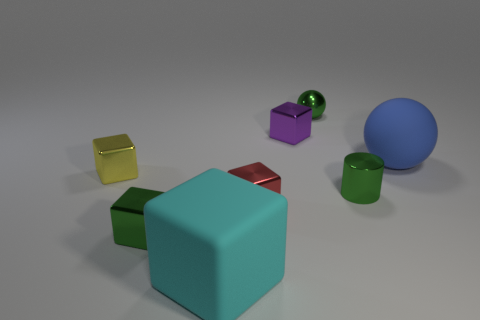What is the object that is both on the right side of the tiny ball and behind the metal cylinder made of?
Provide a short and direct response. Rubber. How many tiny gray matte cylinders are there?
Ensure brevity in your answer.  0. How big is the shiny block behind the big rubber object that is behind the big cyan block?
Ensure brevity in your answer.  Small. How many other objects are there of the same size as the red block?
Keep it short and to the point. 5. What number of small metal blocks are right of the cyan matte block?
Ensure brevity in your answer.  2. What is the size of the yellow object?
Offer a terse response. Small. Do the tiny green thing that is left of the cyan block and the big object that is in front of the large rubber ball have the same material?
Offer a very short reply. No. Is there a shiny cylinder of the same color as the large rubber cube?
Ensure brevity in your answer.  No. There is a shiny cylinder that is the same size as the yellow shiny thing; what is its color?
Make the answer very short. Green. Does the ball behind the small purple metallic cube have the same color as the big rubber sphere?
Offer a very short reply. No. 